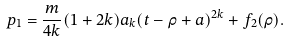<formula> <loc_0><loc_0><loc_500><loc_500>p _ { 1 } = \frac { m } { 4 k } ( 1 + 2 k ) a _ { k } ( t - \rho + a ) ^ { 2 k } + f _ { 2 } ( \rho ) .</formula> 